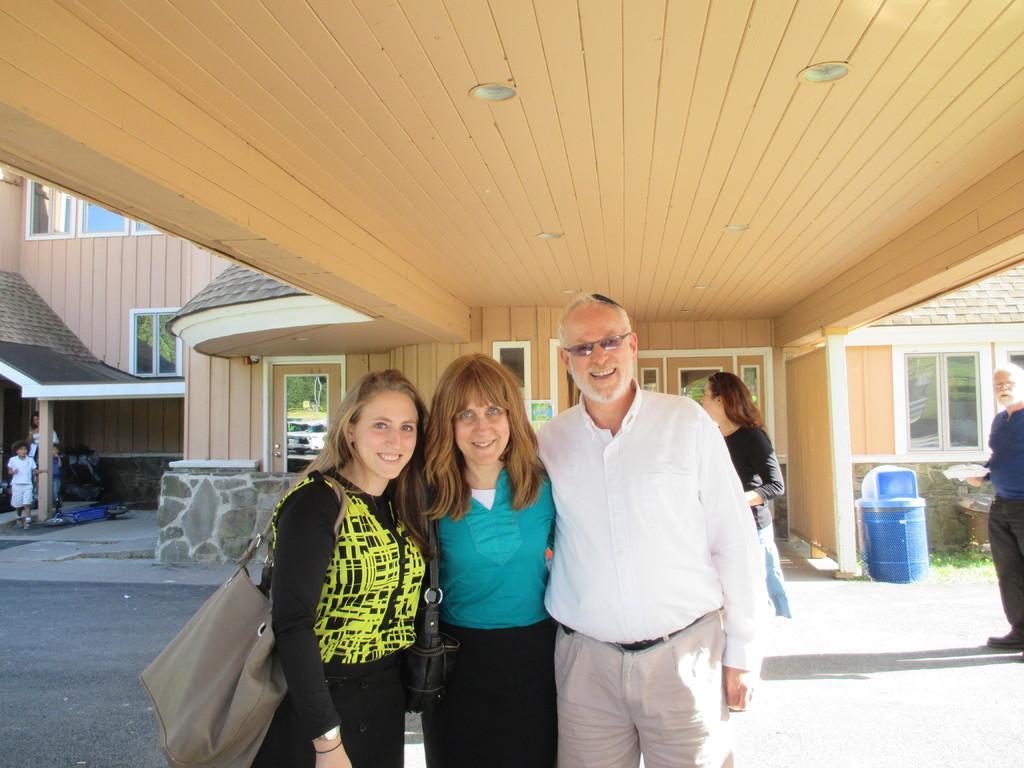In one or two sentences, can you explain what this image depicts? In this image there are three persons standing under the wooden roof. On the left side there is a woman who is wearing the bag. In the middle there is another woman who is also wearing the bag. On the right side there is a man who is wearing the white shirt. In the background there is a building. On the right side there is a dustbin. In the background there are windows. There is a wall on the left side. 